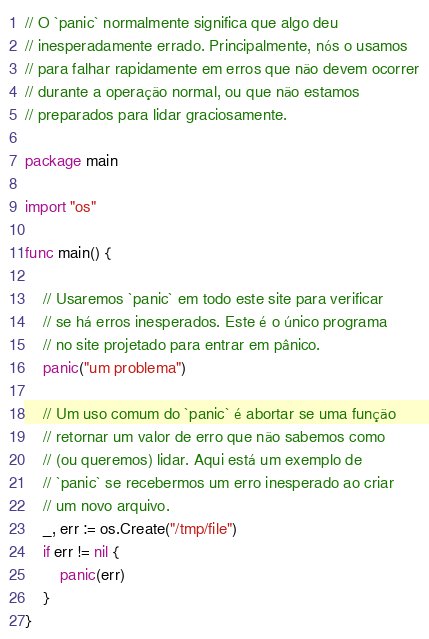<code> <loc_0><loc_0><loc_500><loc_500><_Go_>// O `panic` normalmente significa que algo deu 
// inesperadamente errado. Principalmente, nós o usamos
// para falhar rapidamente em erros que não devem ocorrer
// durante a operação normal, ou que não estamos 
// preparados para lidar graciosamente.

package main

import "os"

func main() {

	// Usaremos `panic` em todo este site para verificar
	// se há erros inesperados. Este é o único programa 
	// no site projetado para entrar em pânico.
	panic("um problema")

	// Um uso comum do `panic` é abortar se uma função
	// retornar um valor de erro que não sabemos como 
	// (ou queremos) lidar. Aqui está um exemplo de 
	// `panic` se recebermos um erro inesperado ao criar
	// um novo arquivo.
	_, err := os.Create("/tmp/file")
	if err != nil {
		panic(err)
	}
}
</code> 